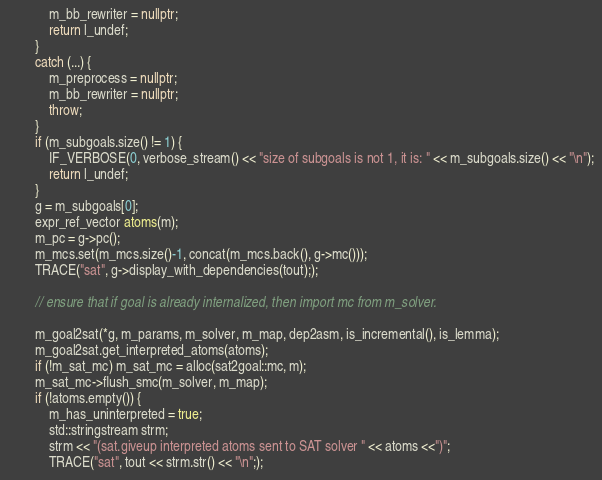Convert code to text. <code><loc_0><loc_0><loc_500><loc_500><_C++_>            m_bb_rewriter = nullptr;
            return l_undef;
        }        
        catch (...) {
            m_preprocess = nullptr;
            m_bb_rewriter = nullptr;
            throw;
        }
        if (m_subgoals.size() != 1) {
            IF_VERBOSE(0, verbose_stream() << "size of subgoals is not 1, it is: " << m_subgoals.size() << "\n");
            return l_undef;
        }
        g = m_subgoals[0];
        expr_ref_vector atoms(m);
        m_pc = g->pc();
        m_mcs.set(m_mcs.size()-1, concat(m_mcs.back(), g->mc()));
        TRACE("sat", g->display_with_dependencies(tout););

        // ensure that if goal is already internalized, then import mc from m_solver.

        m_goal2sat(*g, m_params, m_solver, m_map, dep2asm, is_incremental(), is_lemma);
        m_goal2sat.get_interpreted_atoms(atoms);
        if (!m_sat_mc) m_sat_mc = alloc(sat2goal::mc, m);
        m_sat_mc->flush_smc(m_solver, m_map);
        if (!atoms.empty()) {
            m_has_uninterpreted = true;
            std::stringstream strm;
            strm << "(sat.giveup interpreted atoms sent to SAT solver " << atoms <<")";
            TRACE("sat", tout << strm.str() << "\n";);</code> 